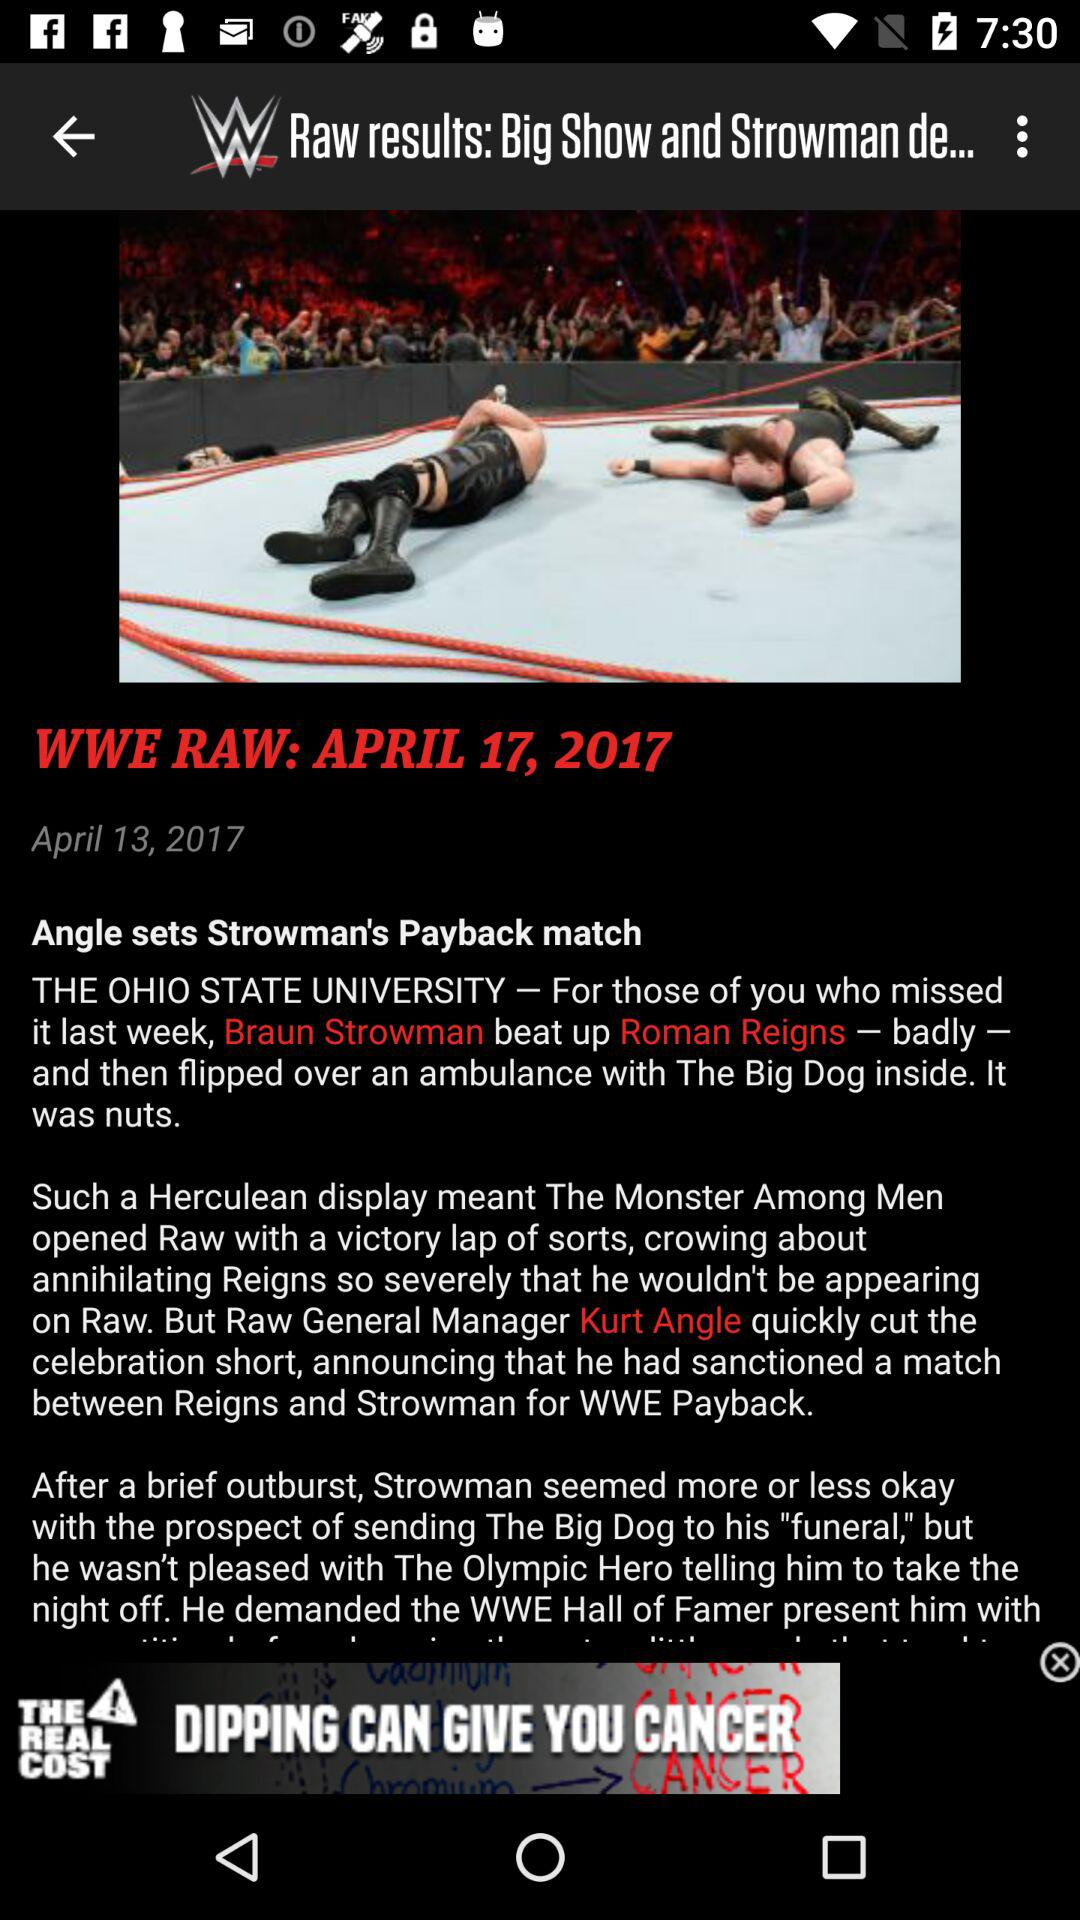Who is Kurt Angle? Kurt Angle is the "Raw General Manager". 